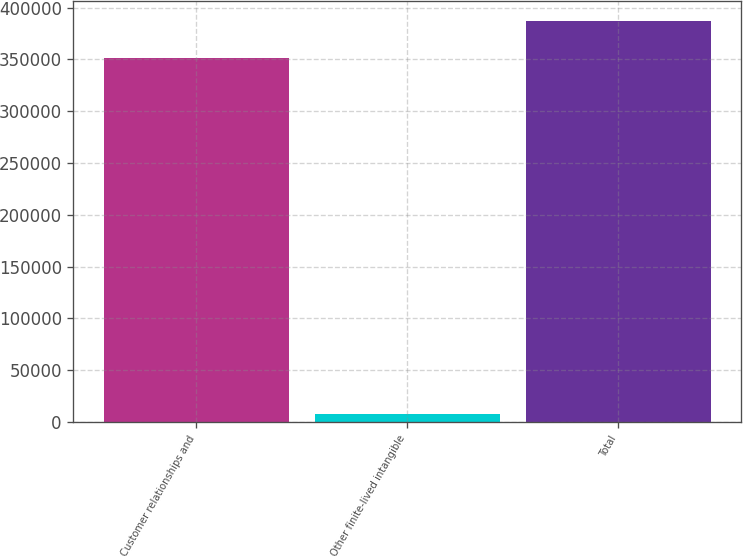<chart> <loc_0><loc_0><loc_500><loc_500><bar_chart><fcel>Customer relationships and<fcel>Other finite-lived intangible<fcel>Total<nl><fcel>351497<fcel>7989<fcel>386647<nl></chart> 